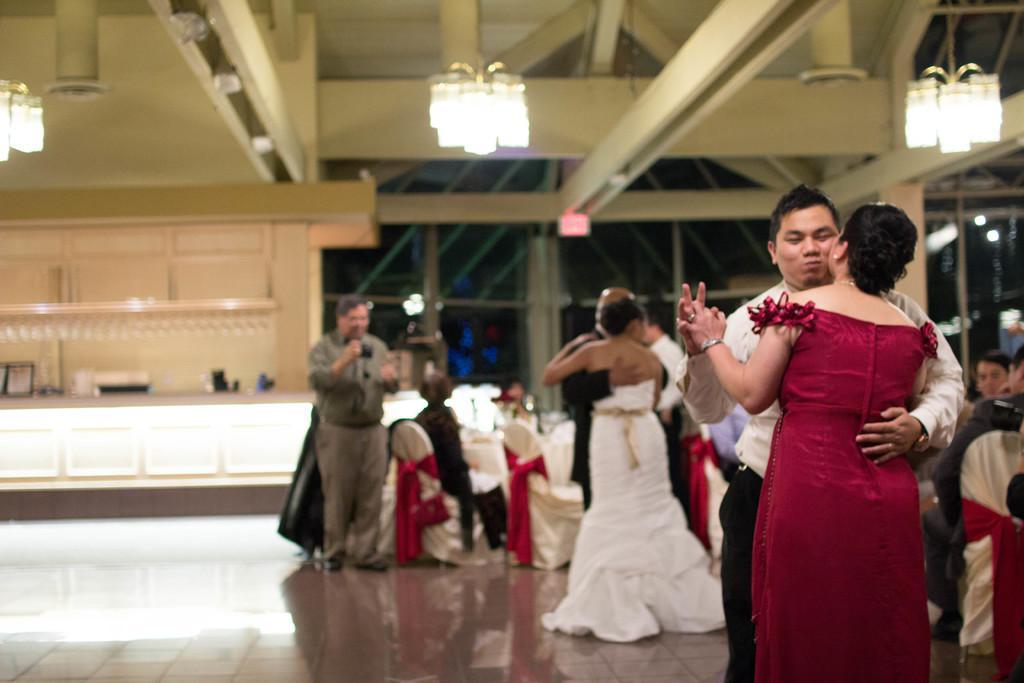How would you summarize this image in a sentence or two? In this image we can see some people standing on the floor and some are sitting on the chairs. In the background there are chandelier and grills. 